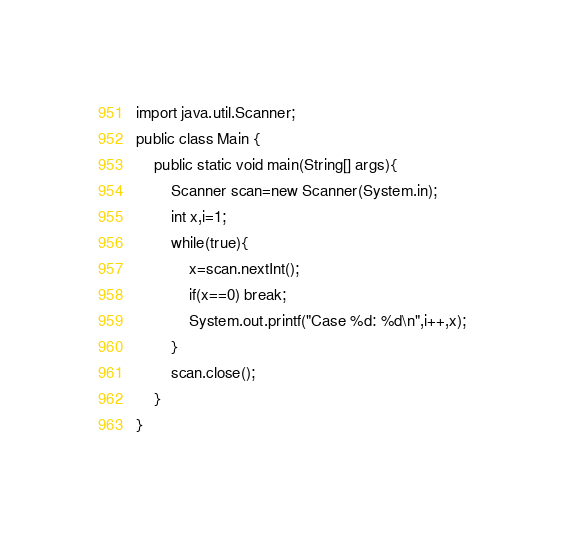<code> <loc_0><loc_0><loc_500><loc_500><_Java_>import java.util.Scanner;
public class Main {
	public static void main(String[] args){
		Scanner scan=new Scanner(System.in);
		int x,i=1;
		while(true){
			x=scan.nextInt();
			if(x==0) break;
			System.out.printf("Case %d: %d\n",i++,x);
		}
		scan.close();
	}
}</code> 